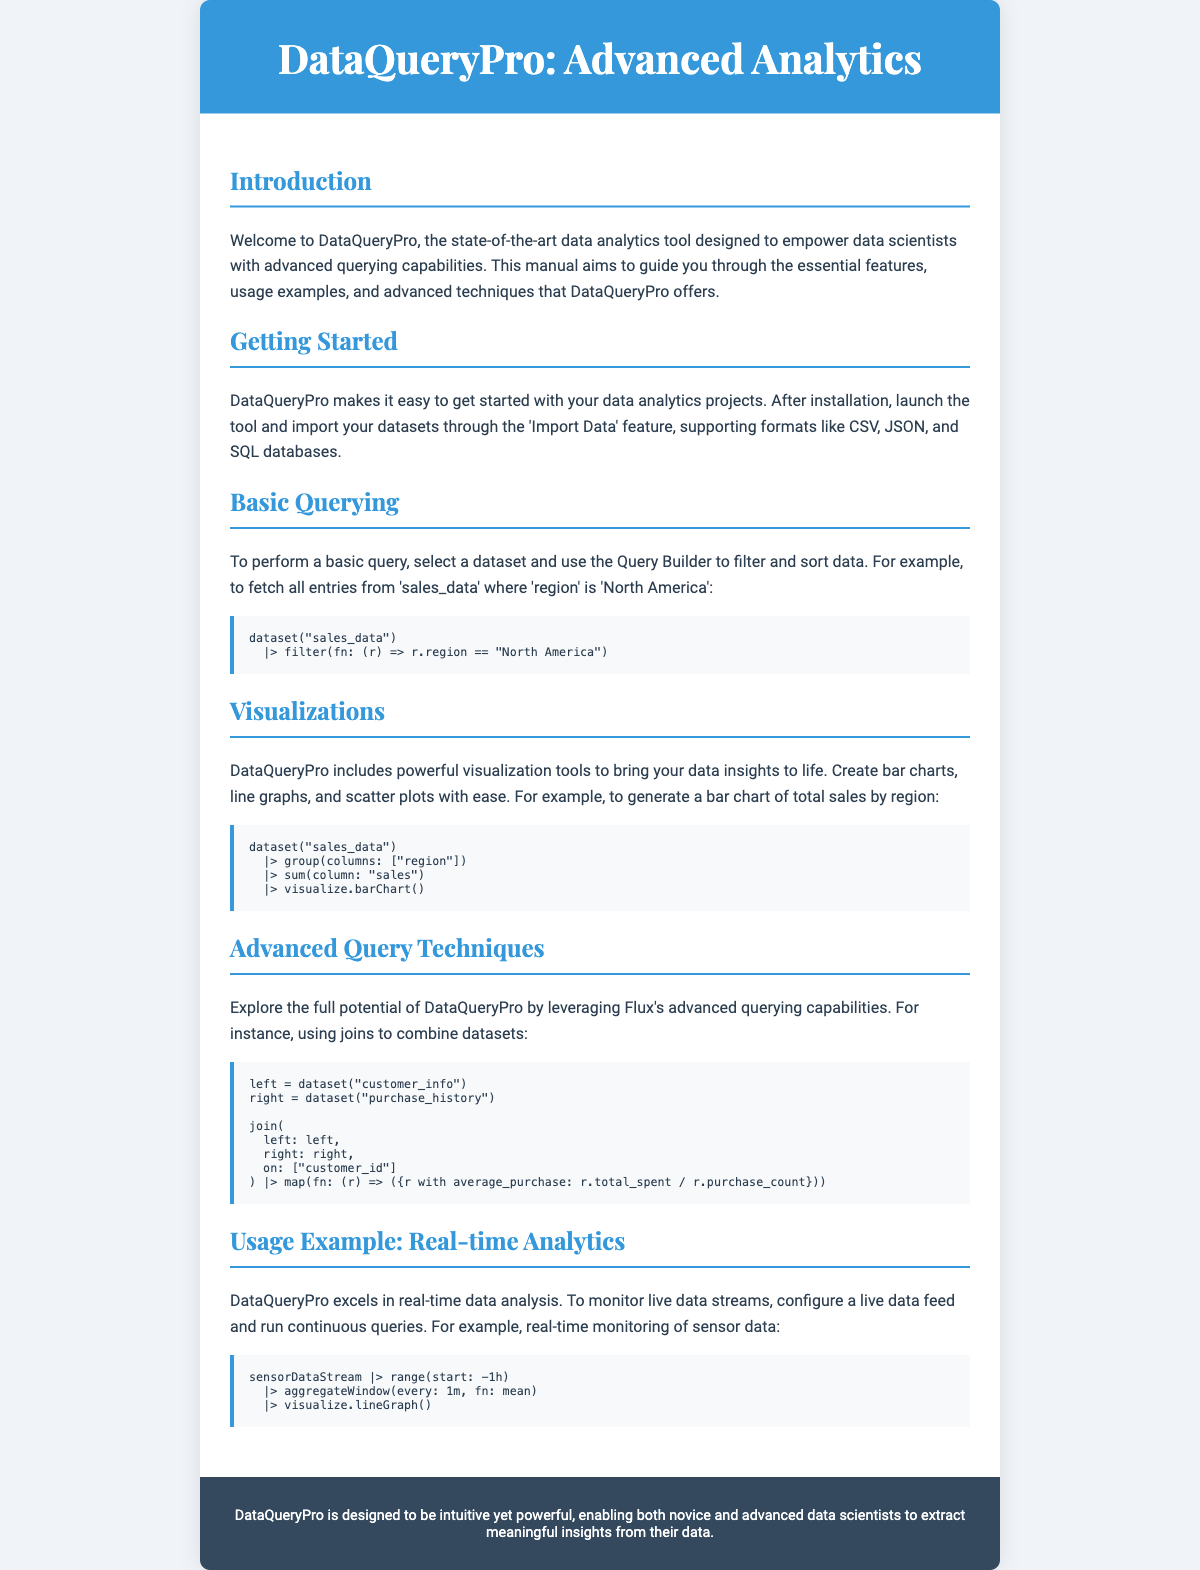What is the name of the data analytics tool? The manual introduces a tool called DataQueryPro.
Answer: DataQueryPro What feature allows importing various data formats? The manual states that the 'Import Data' feature supports formats like CSV, JSON, and SQL databases.
Answer: Import Data What is an example of a simple query provided in the document? The document offers a query example that filters sales data by the 'North America' region.
Answer: North America What type of graph can be generated for total sales by region? The manual mentions creating bar charts among other visualizations.
Answer: bar charts What is the purpose of the advanced query techniques section? The section encourages users to leverage Flux's advanced querying capabilities, such as joins.
Answer: Joins How often does the document suggest aggregating live sensor data? The document states the recommended frequency for aggregating live data is every minute.
Answer: one minute What does DataQueryPro enable for both novice and advanced data scientists? The document indicates that DataQueryPro allows users to extract meaningful insights from their data.
Answer: meaningful insights What visual representation is suggested for monitoring sensor data in real-time? The document suggests using a line graph for visualizing real-time sensor data.
Answer: line graph 